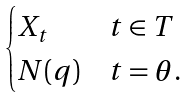<formula> <loc_0><loc_0><loc_500><loc_500>\begin{cases} X _ { t } & t \in T \\ N ( q ) & t = \theta . \end{cases}</formula> 